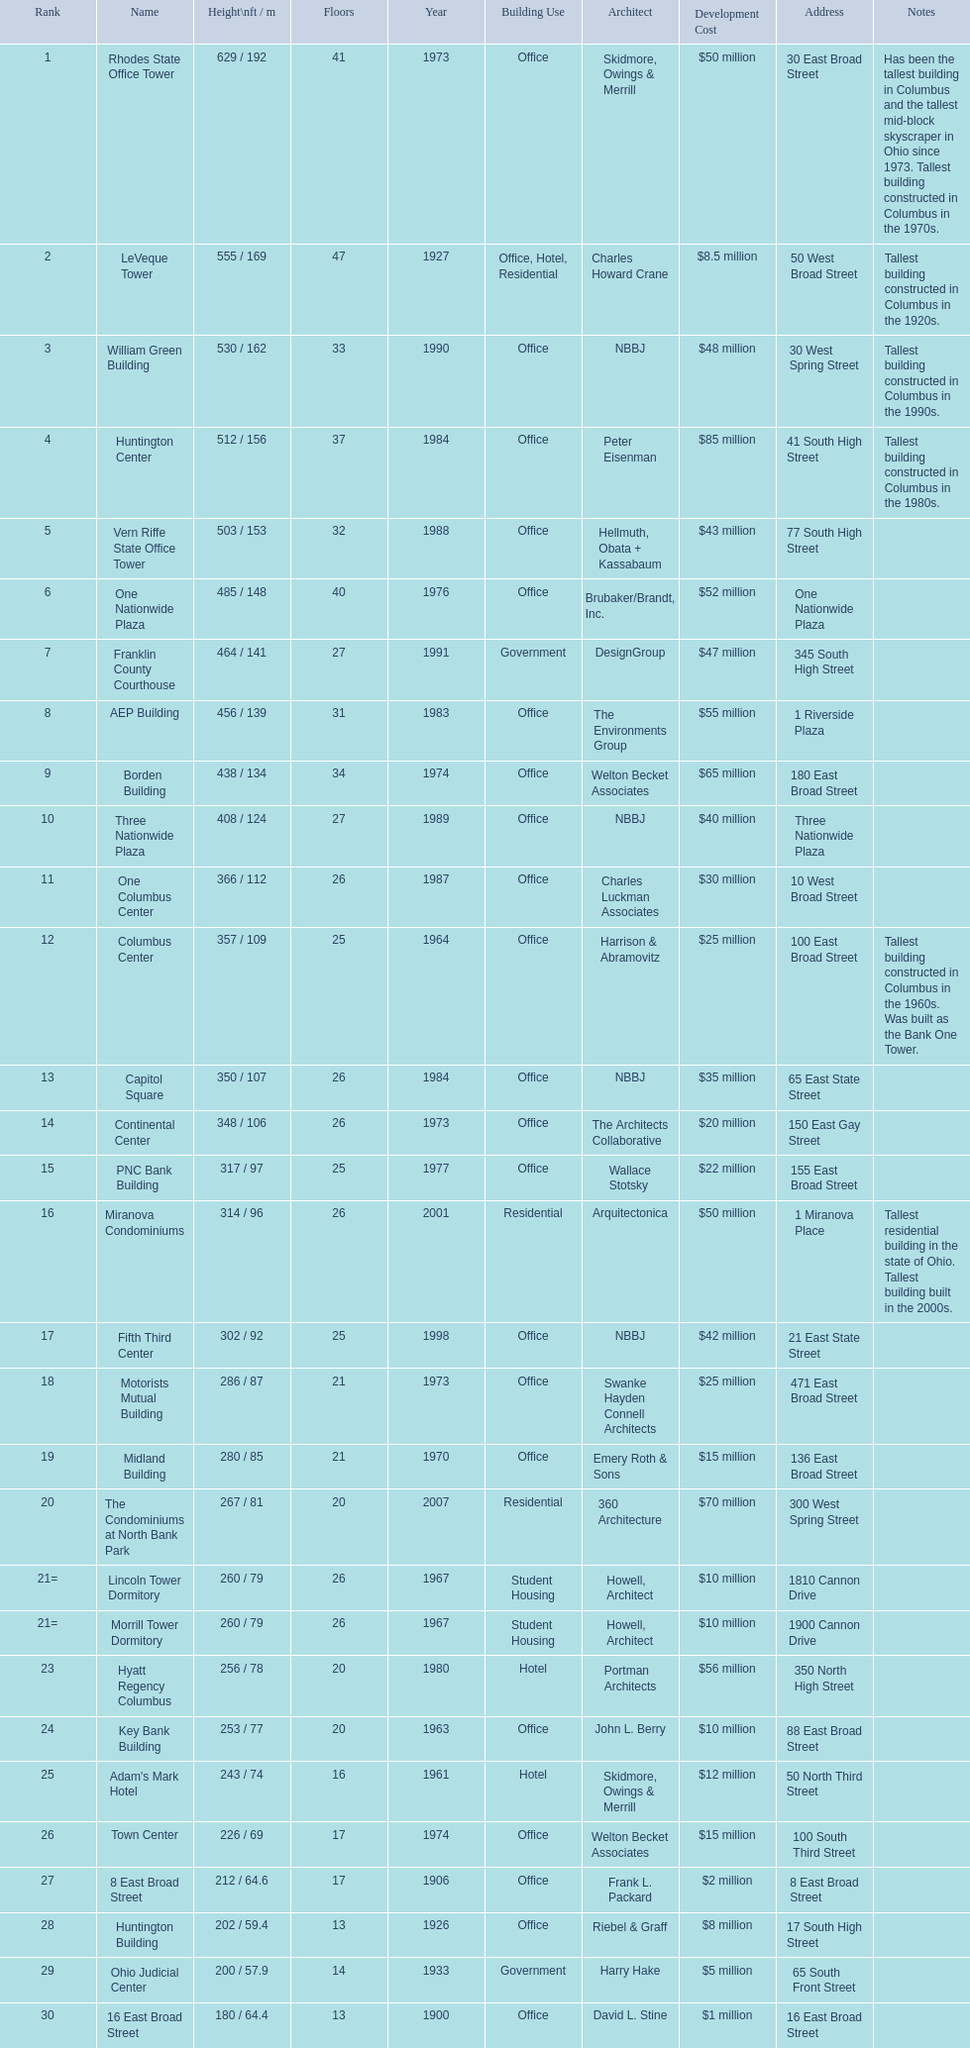What are the heights of all the buildings 629 / 192, 555 / 169, 530 / 162, 512 / 156, 503 / 153, 485 / 148, 464 / 141, 456 / 139, 438 / 134, 408 / 124, 366 / 112, 357 / 109, 350 / 107, 348 / 106, 317 / 97, 314 / 96, 302 / 92, 286 / 87, 280 / 85, 267 / 81, 260 / 79, 260 / 79, 256 / 78, 253 / 77, 243 / 74, 226 / 69, 212 / 64.6, 202 / 59.4, 200 / 57.9, 180 / 64.4. What are the heights of the aep and columbus center buildings 456 / 139, 357 / 109. Which height is greater? 456 / 139. What building is this for? AEP Building. 